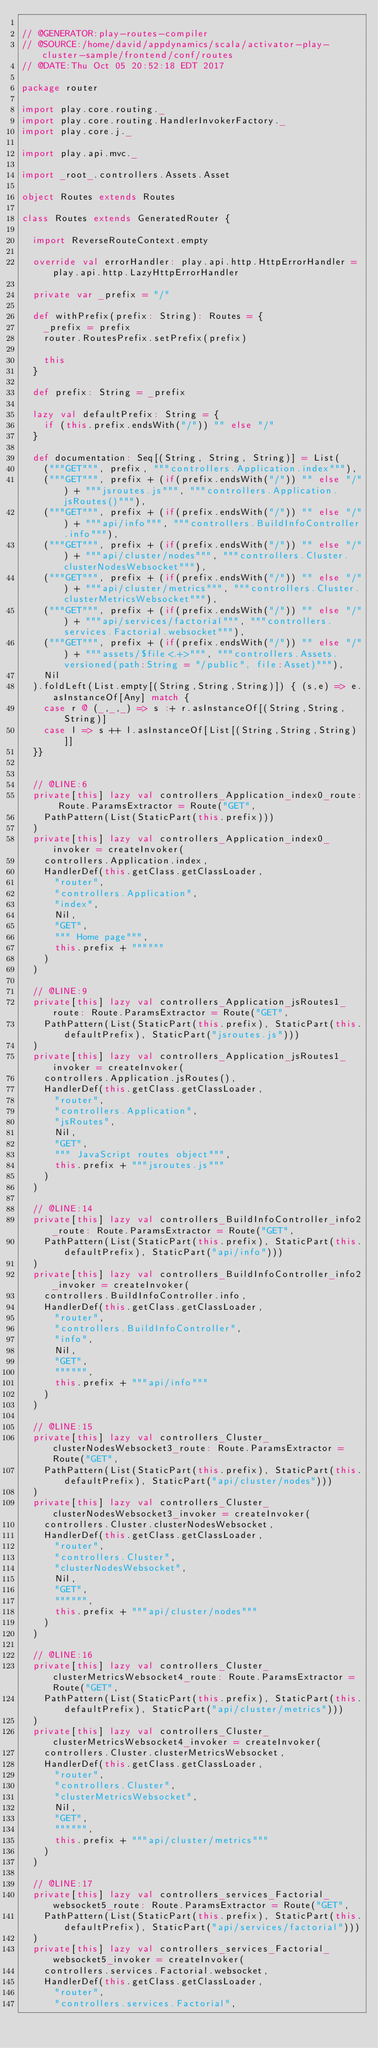Convert code to text. <code><loc_0><loc_0><loc_500><loc_500><_Scala_>
// @GENERATOR:play-routes-compiler
// @SOURCE:/home/david/appdynamics/scala/activator-play-cluster-sample/frontend/conf/routes
// @DATE:Thu Oct 05 20:52:18 EDT 2017

package router

import play.core.routing._
import play.core.routing.HandlerInvokerFactory._
import play.core.j._

import play.api.mvc._

import _root_.controllers.Assets.Asset

object Routes extends Routes

class Routes extends GeneratedRouter {

  import ReverseRouteContext.empty

  override val errorHandler: play.api.http.HttpErrorHandler = play.api.http.LazyHttpErrorHandler

  private var _prefix = "/"

  def withPrefix(prefix: String): Routes = {
    _prefix = prefix
    router.RoutesPrefix.setPrefix(prefix)
    
    this
  }

  def prefix: String = _prefix

  lazy val defaultPrefix: String = {
    if (this.prefix.endsWith("/")) "" else "/"
  }

  def documentation: Seq[(String, String, String)] = List(
    ("""GET""", prefix, """controllers.Application.index"""),
    ("""GET""", prefix + (if(prefix.endsWith("/")) "" else "/") + """jsroutes.js""", """controllers.Application.jsRoutes()"""),
    ("""GET""", prefix + (if(prefix.endsWith("/")) "" else "/") + """api/info""", """controllers.BuildInfoController.info"""),
    ("""GET""", prefix + (if(prefix.endsWith("/")) "" else "/") + """api/cluster/nodes""", """controllers.Cluster.clusterNodesWebsocket"""),
    ("""GET""", prefix + (if(prefix.endsWith("/")) "" else "/") + """api/cluster/metrics""", """controllers.Cluster.clusterMetricsWebsocket"""),
    ("""GET""", prefix + (if(prefix.endsWith("/")) "" else "/") + """api/services/factorial""", """controllers.services.Factorial.websocket"""),
    ("""GET""", prefix + (if(prefix.endsWith("/")) "" else "/") + """assets/$file<.+>""", """controllers.Assets.versioned(path:String = "/public", file:Asset)"""),
    Nil
  ).foldLeft(List.empty[(String,String,String)]) { (s,e) => e.asInstanceOf[Any] match {
    case r @ (_,_,_) => s :+ r.asInstanceOf[(String,String,String)]
    case l => s ++ l.asInstanceOf[List[(String,String,String)]]
  }}


  // @LINE:6
  private[this] lazy val controllers_Application_index0_route: Route.ParamsExtractor = Route("GET",
    PathPattern(List(StaticPart(this.prefix)))
  )
  private[this] lazy val controllers_Application_index0_invoker = createInvoker(
    controllers.Application.index,
    HandlerDef(this.getClass.getClassLoader,
      "router",
      "controllers.Application",
      "index",
      Nil,
      "GET",
      """ Home page""",
      this.prefix + """"""
    )
  )

  // @LINE:9
  private[this] lazy val controllers_Application_jsRoutes1_route: Route.ParamsExtractor = Route("GET",
    PathPattern(List(StaticPart(this.prefix), StaticPart(this.defaultPrefix), StaticPart("jsroutes.js")))
  )
  private[this] lazy val controllers_Application_jsRoutes1_invoker = createInvoker(
    controllers.Application.jsRoutes(),
    HandlerDef(this.getClass.getClassLoader,
      "router",
      "controllers.Application",
      "jsRoutes",
      Nil,
      "GET",
      """ JavaScript routes object""",
      this.prefix + """jsroutes.js"""
    )
  )

  // @LINE:14
  private[this] lazy val controllers_BuildInfoController_info2_route: Route.ParamsExtractor = Route("GET",
    PathPattern(List(StaticPart(this.prefix), StaticPart(this.defaultPrefix), StaticPart("api/info")))
  )
  private[this] lazy val controllers_BuildInfoController_info2_invoker = createInvoker(
    controllers.BuildInfoController.info,
    HandlerDef(this.getClass.getClassLoader,
      "router",
      "controllers.BuildInfoController",
      "info",
      Nil,
      "GET",
      """""",
      this.prefix + """api/info"""
    )
  )

  // @LINE:15
  private[this] lazy val controllers_Cluster_clusterNodesWebsocket3_route: Route.ParamsExtractor = Route("GET",
    PathPattern(List(StaticPart(this.prefix), StaticPart(this.defaultPrefix), StaticPart("api/cluster/nodes")))
  )
  private[this] lazy val controllers_Cluster_clusterNodesWebsocket3_invoker = createInvoker(
    controllers.Cluster.clusterNodesWebsocket,
    HandlerDef(this.getClass.getClassLoader,
      "router",
      "controllers.Cluster",
      "clusterNodesWebsocket",
      Nil,
      "GET",
      """""",
      this.prefix + """api/cluster/nodes"""
    )
  )

  // @LINE:16
  private[this] lazy val controllers_Cluster_clusterMetricsWebsocket4_route: Route.ParamsExtractor = Route("GET",
    PathPattern(List(StaticPart(this.prefix), StaticPart(this.defaultPrefix), StaticPart("api/cluster/metrics")))
  )
  private[this] lazy val controllers_Cluster_clusterMetricsWebsocket4_invoker = createInvoker(
    controllers.Cluster.clusterMetricsWebsocket,
    HandlerDef(this.getClass.getClassLoader,
      "router",
      "controllers.Cluster",
      "clusterMetricsWebsocket",
      Nil,
      "GET",
      """""",
      this.prefix + """api/cluster/metrics"""
    )
  )

  // @LINE:17
  private[this] lazy val controllers_services_Factorial_websocket5_route: Route.ParamsExtractor = Route("GET",
    PathPattern(List(StaticPart(this.prefix), StaticPart(this.defaultPrefix), StaticPart("api/services/factorial")))
  )
  private[this] lazy val controllers_services_Factorial_websocket5_invoker = createInvoker(
    controllers.services.Factorial.websocket,
    HandlerDef(this.getClass.getClassLoader,
      "router",
      "controllers.services.Factorial",</code> 